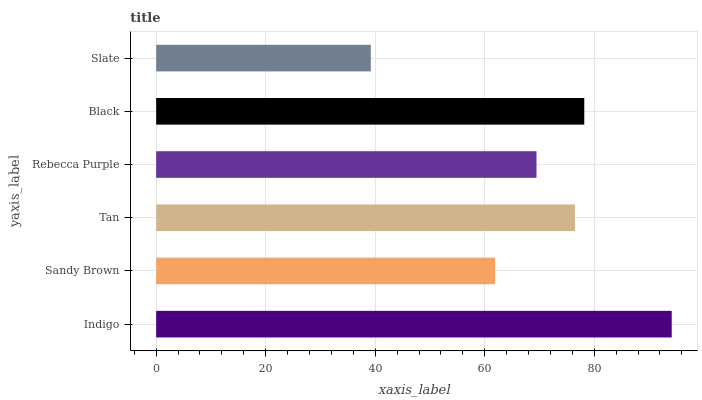Is Slate the minimum?
Answer yes or no. Yes. Is Indigo the maximum?
Answer yes or no. Yes. Is Sandy Brown the minimum?
Answer yes or no. No. Is Sandy Brown the maximum?
Answer yes or no. No. Is Indigo greater than Sandy Brown?
Answer yes or no. Yes. Is Sandy Brown less than Indigo?
Answer yes or no. Yes. Is Sandy Brown greater than Indigo?
Answer yes or no. No. Is Indigo less than Sandy Brown?
Answer yes or no. No. Is Tan the high median?
Answer yes or no. Yes. Is Rebecca Purple the low median?
Answer yes or no. Yes. Is Rebecca Purple the high median?
Answer yes or no. No. Is Sandy Brown the low median?
Answer yes or no. No. 